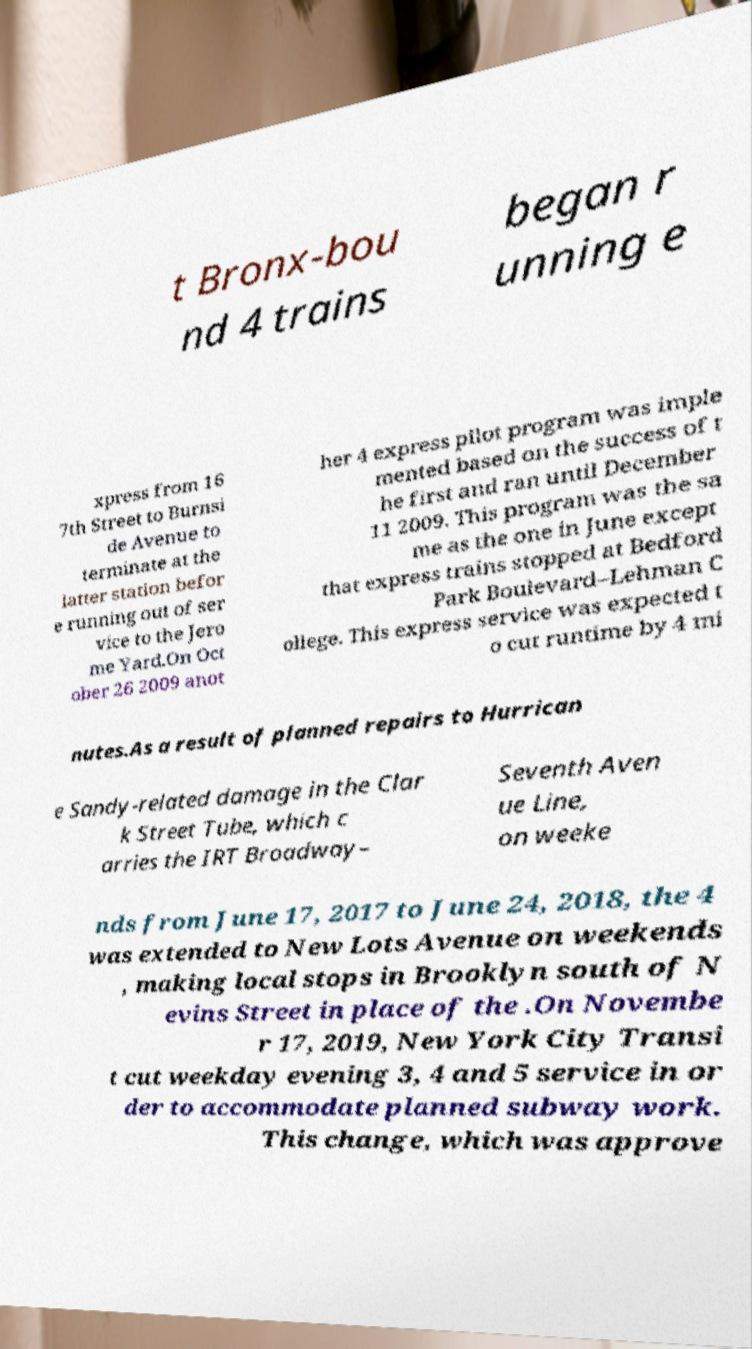Could you assist in decoding the text presented in this image and type it out clearly? t Bronx-bou nd 4 trains began r unning e xpress from 16 7th Street to Burnsi de Avenue to terminate at the latter station befor e running out of ser vice to the Jero me Yard.On Oct ober 26 2009 anot her 4 express pilot program was imple mented based on the success of t he first and ran until December 11 2009. This program was the sa me as the one in June except that express trains stopped at Bedford Park Boulevard–Lehman C ollege. This express service was expected t o cut runtime by 4 mi nutes.As a result of planned repairs to Hurrican e Sandy-related damage in the Clar k Street Tube, which c arries the IRT Broadway– Seventh Aven ue Line, on weeke nds from June 17, 2017 to June 24, 2018, the 4 was extended to New Lots Avenue on weekends , making local stops in Brooklyn south of N evins Street in place of the .On Novembe r 17, 2019, New York City Transi t cut weekday evening 3, 4 and 5 service in or der to accommodate planned subway work. This change, which was approve 